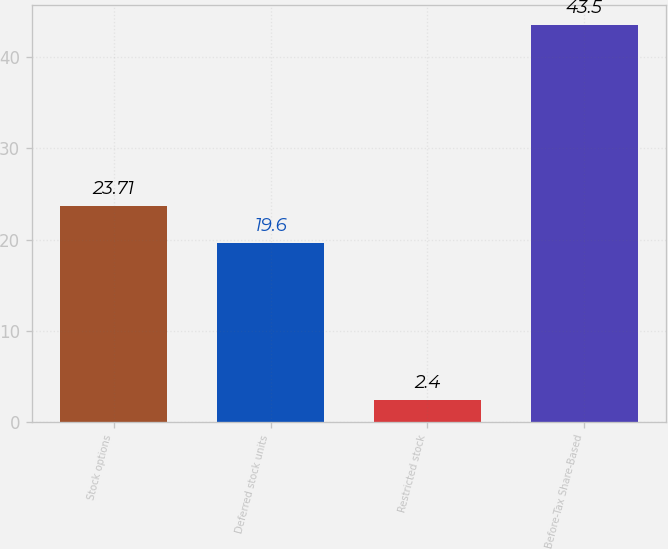<chart> <loc_0><loc_0><loc_500><loc_500><bar_chart><fcel>Stock options<fcel>Deferred stock units<fcel>Restricted stock<fcel>Before-Tax Share-Based<nl><fcel>23.71<fcel>19.6<fcel>2.4<fcel>43.5<nl></chart> 